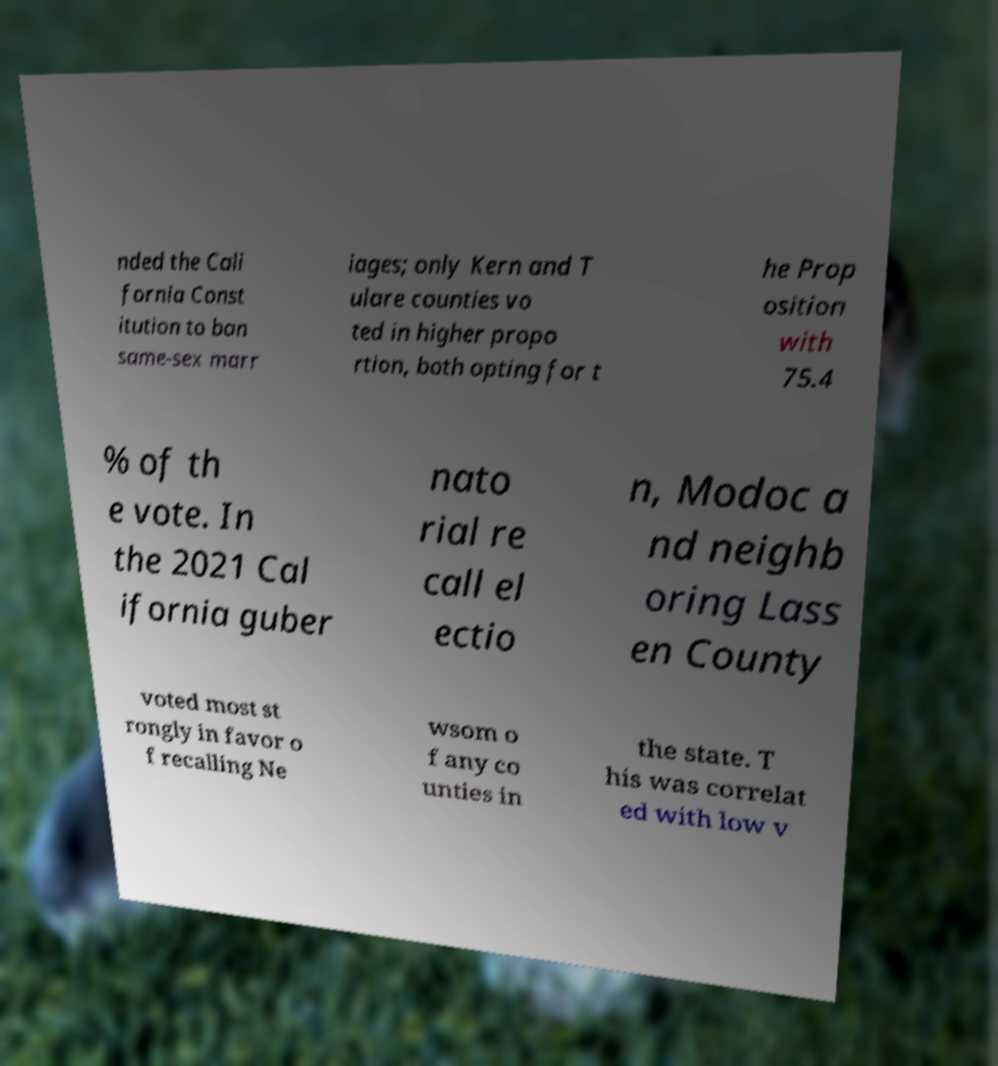Could you assist in decoding the text presented in this image and type it out clearly? nded the Cali fornia Const itution to ban same-sex marr iages; only Kern and T ulare counties vo ted in higher propo rtion, both opting for t he Prop osition with 75.4 % of th e vote. In the 2021 Cal ifornia guber nato rial re call el ectio n, Modoc a nd neighb oring Lass en County voted most st rongly in favor o f recalling Ne wsom o f any co unties in the state. T his was correlat ed with low v 